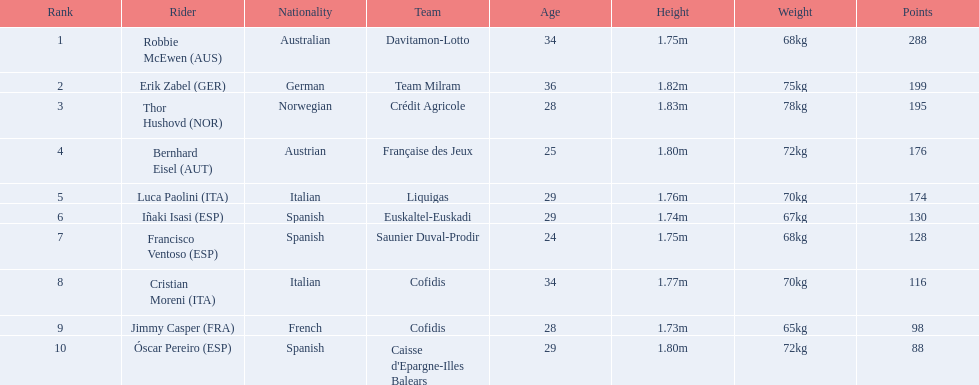How many more points did erik zabel score than franciso ventoso? 71. 